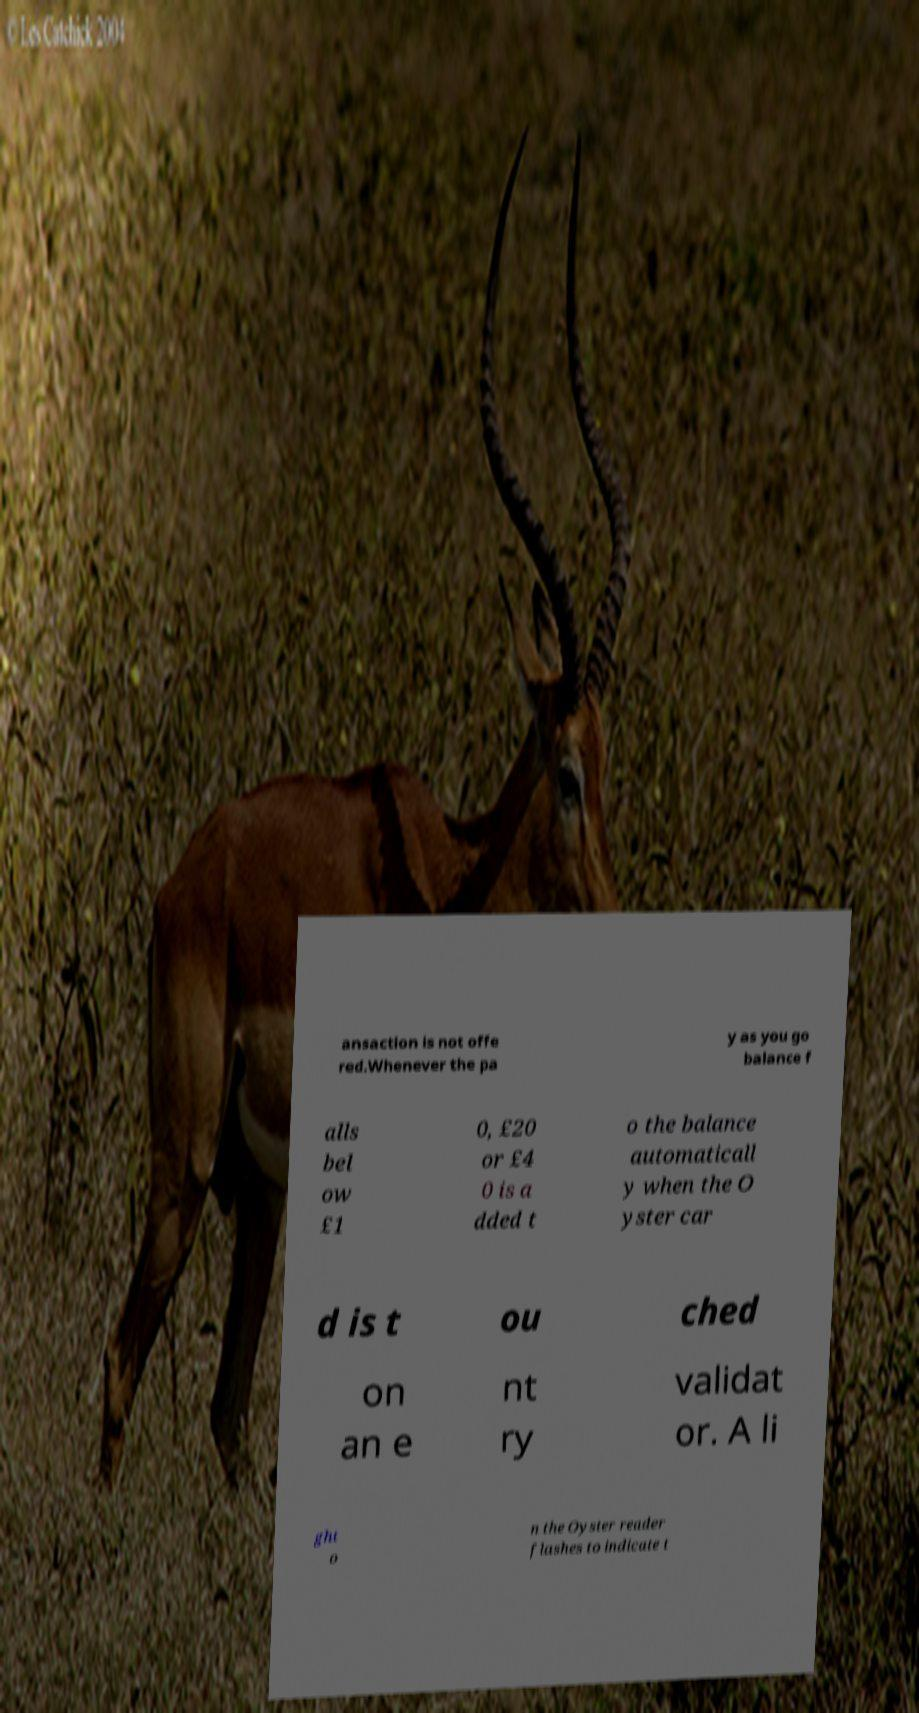Can you read and provide the text displayed in the image?This photo seems to have some interesting text. Can you extract and type it out for me? ansaction is not offe red.Whenever the pa y as you go balance f alls bel ow £1 0, £20 or £4 0 is a dded t o the balance automaticall y when the O yster car d is t ou ched on an e nt ry validat or. A li ght o n the Oyster reader flashes to indicate t 